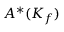Convert formula to latex. <formula><loc_0><loc_0><loc_500><loc_500>A ^ { * } ( K _ { f } )</formula> 